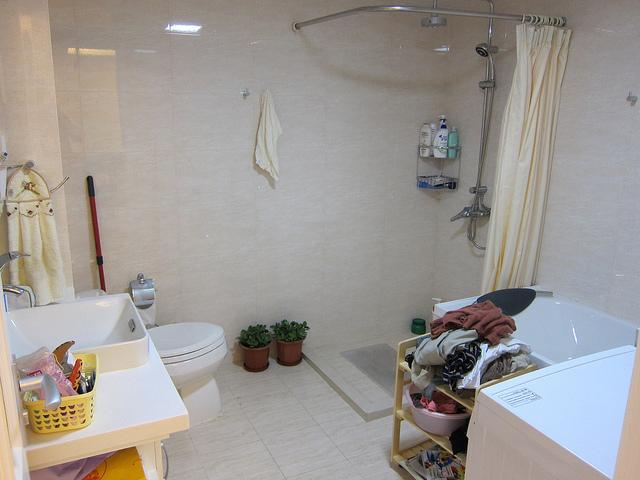Is this bathroom clean?
Keep it brief. Yes. Is the home neat?
Quick response, please. Yes. What is in the bottle on the left?
Quick response, please. Shampoo. How many plants are in the picture?
Short answer required. 2. What position is the toilet lid in?
Be succinct. Down. 